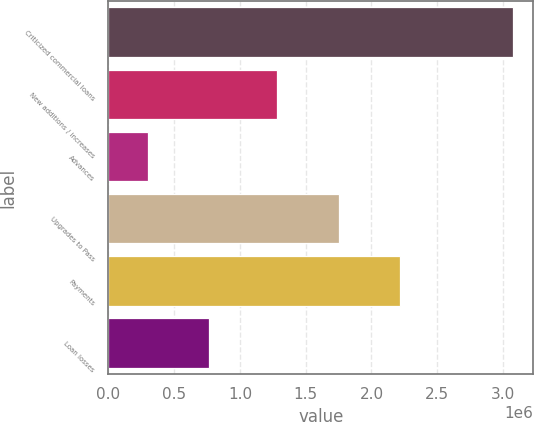Convert chart to OTSL. <chart><loc_0><loc_0><loc_500><loc_500><bar_chart><fcel>Criticized commercial loans<fcel>New additions / increases<fcel>Advances<fcel>Upgrades to Pass<fcel>Payments<fcel>Loan losses<nl><fcel>3.07448e+06<fcel>1.28422e+06<fcel>298511<fcel>1.75153e+06<fcel>2.21884e+06<fcel>765824<nl></chart> 